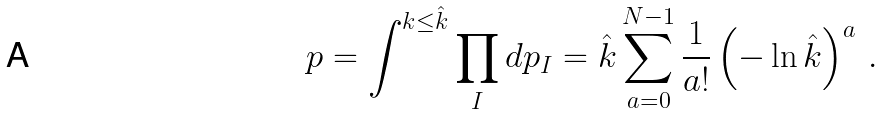Convert formula to latex. <formula><loc_0><loc_0><loc_500><loc_500>p = \int ^ { k \leq \hat { k } } \prod _ { I } d p _ { I } = \hat { k } \sum _ { a = 0 } ^ { N - 1 } \frac { 1 } { a ! } \left ( - \ln \hat { k } \right ) ^ { a } \, .</formula> 